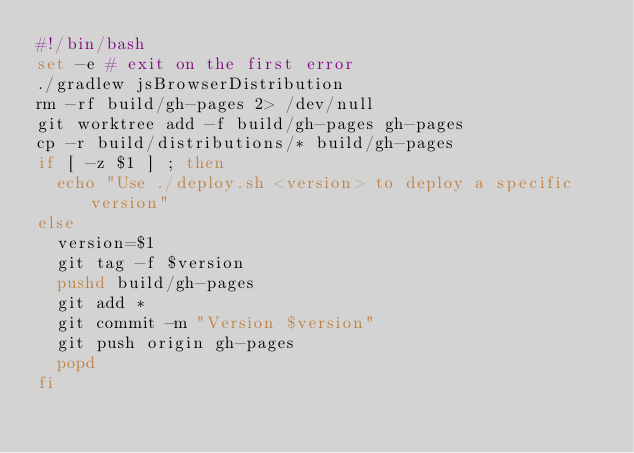Convert code to text. <code><loc_0><loc_0><loc_500><loc_500><_Bash_>#!/bin/bash
set -e # exit on the first error
./gradlew jsBrowserDistribution
rm -rf build/gh-pages 2> /dev/null
git worktree add -f build/gh-pages gh-pages
cp -r build/distributions/* build/gh-pages
if [ -z $1 ] ; then
  echo "Use ./deploy.sh <version> to deploy a specific version"
else
  version=$1
  git tag -f $version
  pushd build/gh-pages
  git add *
  git commit -m "Version $version"
  git push origin gh-pages
  popd
fi</code> 